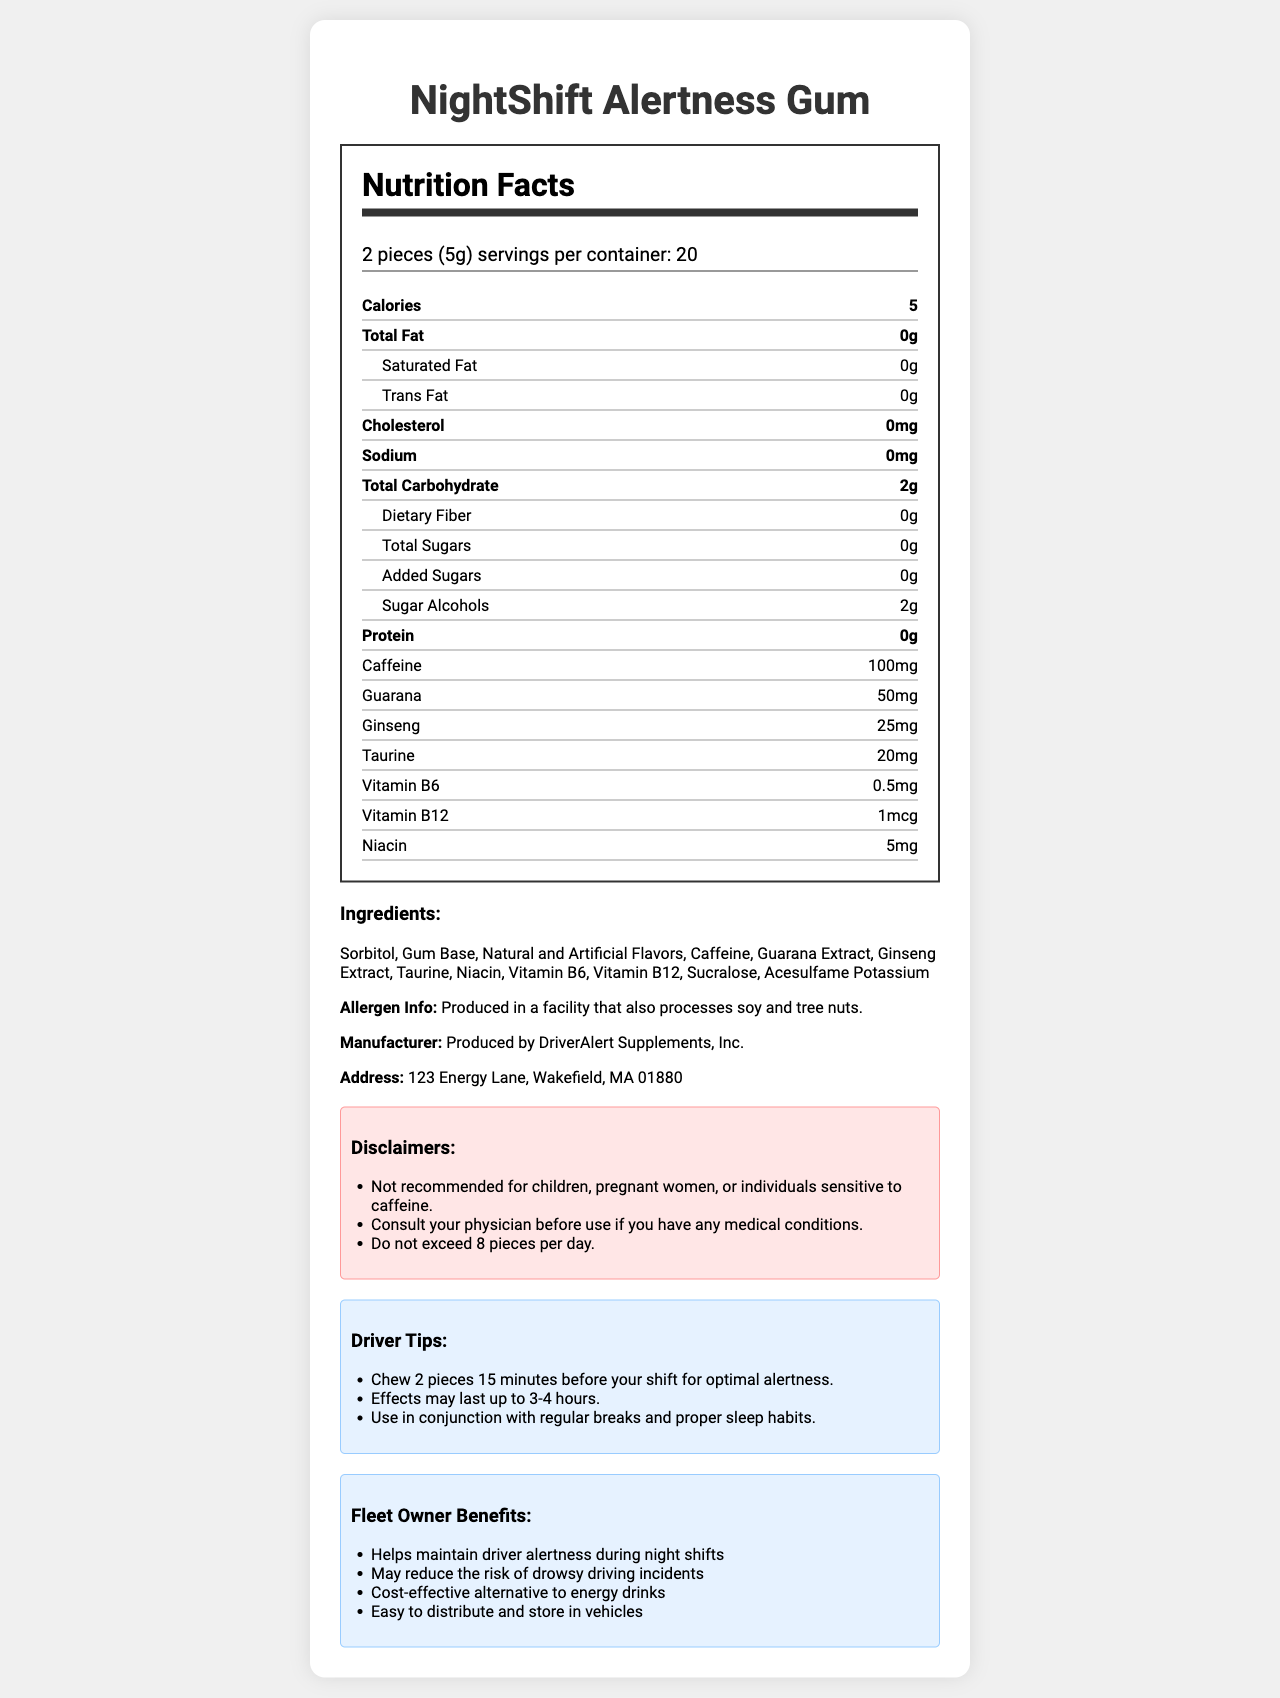What is the serving size for NightShift Alertness Gum? The serving size information is clearly stated as "2 pieces (5g)" on the nutrition facts section.
Answer: 2 pieces (5g) How many calories are in one serving of NightShift Alertness Gum? The document lists "calories: 5" under the nutrition facts.
Answer: 5 calories What is the caffeine content per serving? The nutrition facts list "caffeine: 100mg" under the nutrient information.
Answer: 100mg How many servings are in one container? The number of servings per container is mentioned as "20" in the nutrition facts.
Answer: 20 Are there any added sugars in NightShift Alertness Gum? The document specifies "added sugars: 0g" in the nutrition facts.
Answer: No What is the main purpose of NightShift Alertness Gum? A. To help with sleep issues B. To improve digestion C. To help drivers stay alert The product name and the purpose of the gum are indicated as being designed for driver alertness during night shifts.
Answer: C Who should avoid using this gum according to the disclaimers? A. Children B. Pregnant women C. Individuals sensitive to caffeine D. All of the above The disclaimers section states "Not recommended for children, pregnant women, or individuals sensitive to caffeine."
Answer: D Does NightShift Alertness Gum contain any protein? The nutrition facts indicate "protein: 0g."
Answer: No Is NightShift Alertness Gum produced in a facility that processes soy and tree nuts? The allergen info indicates that the gum is produced in a facility that also processes soy and tree nuts.
Answer: Yes What additional advice is given for using this gum during a night shift? The driver tips section provides these specific instructions for best results.
Answer: Chew 2 pieces 15 minutes before your shift for optimal alertness. Effects may last up to 3-4 hours. Use in conjunction with regular breaks and proper sleep habits. Does NightShift Alertness Gum contain any dietary fiber? The nutrition facts show "dietary fiber: 0g."
Answer: No What are some of the benefits for fleet owners in using NightShift Alertness Gum in their fleet? The "fleet owner benefits" section lists these benefits explicitly.
Answer: Helps maintain driver alertness during night shifts, May reduce the risk of drowsy driving incidents, Cost-effective alternative to energy drinks, Easy to distribute and store in vehicles Describe the entire document or the main idea of the document. This summary encapsulates all the primary sections and the core purpose of the document.
Answer: The document provides detailed nutrition facts, ingredients, allergen information, manufacturer details, disclaimers, driver tips, and benefits of using NightShift Alertness Gum. The product is designed to help drivers stay alert during night shifts, offering various nutrients and stimulants like caffeine, guarana, and ginseng. It highlights the gum's usefulness for fleet owners and provides guidelines for safe usage. Are there any vitamins included in NightShift Alertness Gum? The nutrition facts mention several vitamins: Vitamin B6 (0.5mg), Vitamin B12 (1mcg), and Niacin (5mg).
Answer: Yes What is the total carbohydrate content per serving? The nutrition facts list "total carbohydrate: 2g."
Answer: 2g How should one store NightShift Alertness Gum to maintain its quality? The document does not provide any specific storage instructions for the gum.
Answer: Cannot be determined Is it safe for someone with a nut allergy to consume this gum? The allergen info notes the gum is produced in a facility that processes soy and tree nuts, but it does not provide specific safety assurances for those with nut allergies.
Answer: Not enough information 